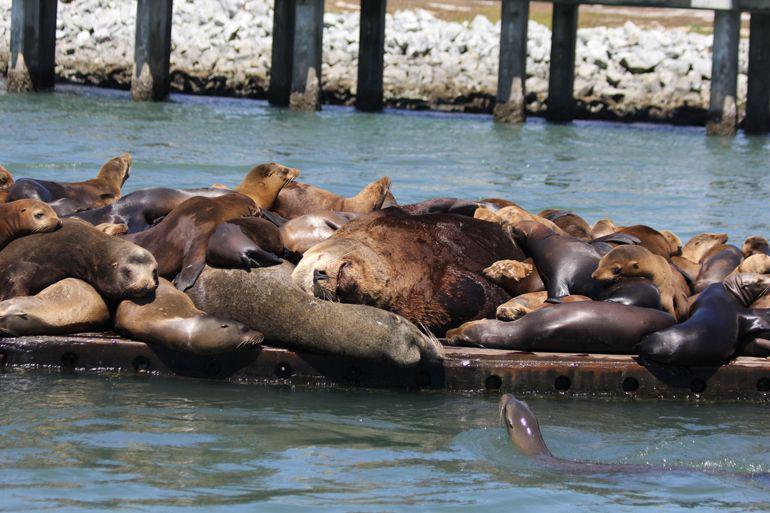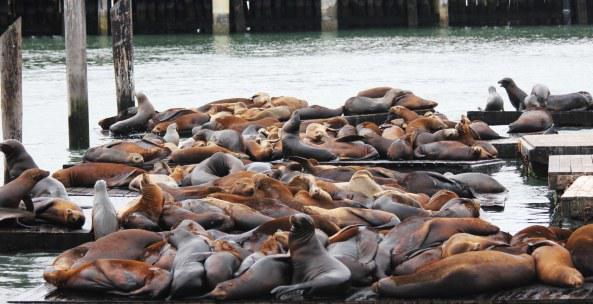The first image is the image on the left, the second image is the image on the right. Analyze the images presented: Is the assertion "A seal's head shows above the water in front of a floating platform packed with seals, in the left image." valid? Answer yes or no. Yes. 